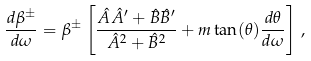<formula> <loc_0><loc_0><loc_500><loc_500>\frac { d \beta ^ { \pm } } { d \omega } = \beta ^ { \pm } \left [ \frac { \hat { A } \hat { A } ^ { \prime } + \hat { B } \hat { B } ^ { \prime } } { \hat { A } ^ { 2 } + \hat { B } ^ { 2 } } + m \tan ( \theta ) \frac { d \theta } { d \omega } \right ] \, ,</formula> 